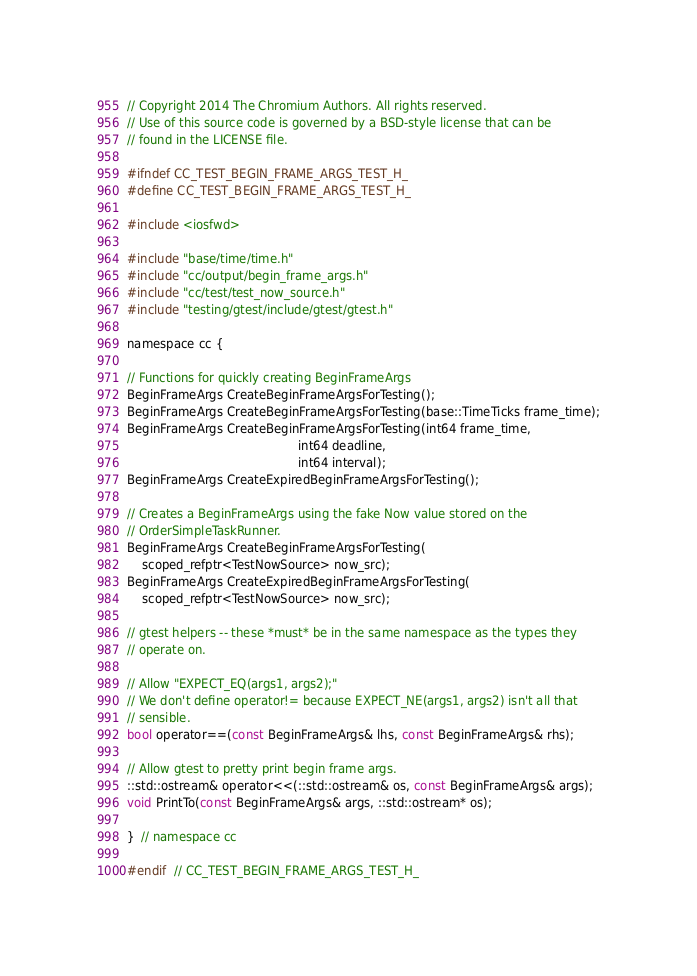Convert code to text. <code><loc_0><loc_0><loc_500><loc_500><_C_>// Copyright 2014 The Chromium Authors. All rights reserved.
// Use of this source code is governed by a BSD-style license that can be
// found in the LICENSE file.

#ifndef CC_TEST_BEGIN_FRAME_ARGS_TEST_H_
#define CC_TEST_BEGIN_FRAME_ARGS_TEST_H_

#include <iosfwd>

#include "base/time/time.h"
#include "cc/output/begin_frame_args.h"
#include "cc/test/test_now_source.h"
#include "testing/gtest/include/gtest/gtest.h"

namespace cc {

// Functions for quickly creating BeginFrameArgs
BeginFrameArgs CreateBeginFrameArgsForTesting();
BeginFrameArgs CreateBeginFrameArgsForTesting(base::TimeTicks frame_time);
BeginFrameArgs CreateBeginFrameArgsForTesting(int64 frame_time,
                                              int64 deadline,
                                              int64 interval);
BeginFrameArgs CreateExpiredBeginFrameArgsForTesting();

// Creates a BeginFrameArgs using the fake Now value stored on the
// OrderSimpleTaskRunner.
BeginFrameArgs CreateBeginFrameArgsForTesting(
    scoped_refptr<TestNowSource> now_src);
BeginFrameArgs CreateExpiredBeginFrameArgsForTesting(
    scoped_refptr<TestNowSource> now_src);

// gtest helpers -- these *must* be in the same namespace as the types they
// operate on.

// Allow "EXPECT_EQ(args1, args2);"
// We don't define operator!= because EXPECT_NE(args1, args2) isn't all that
// sensible.
bool operator==(const BeginFrameArgs& lhs, const BeginFrameArgs& rhs);

// Allow gtest to pretty print begin frame args.
::std::ostream& operator<<(::std::ostream& os, const BeginFrameArgs& args);
void PrintTo(const BeginFrameArgs& args, ::std::ostream* os);

}  // namespace cc

#endif  // CC_TEST_BEGIN_FRAME_ARGS_TEST_H_
</code> 